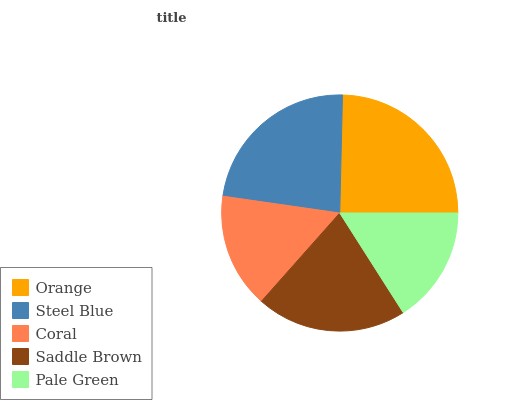Is Coral the minimum?
Answer yes or no. Yes. Is Orange the maximum?
Answer yes or no. Yes. Is Steel Blue the minimum?
Answer yes or no. No. Is Steel Blue the maximum?
Answer yes or no. No. Is Orange greater than Steel Blue?
Answer yes or no. Yes. Is Steel Blue less than Orange?
Answer yes or no. Yes. Is Steel Blue greater than Orange?
Answer yes or no. No. Is Orange less than Steel Blue?
Answer yes or no. No. Is Saddle Brown the high median?
Answer yes or no. Yes. Is Saddle Brown the low median?
Answer yes or no. Yes. Is Pale Green the high median?
Answer yes or no. No. Is Pale Green the low median?
Answer yes or no. No. 